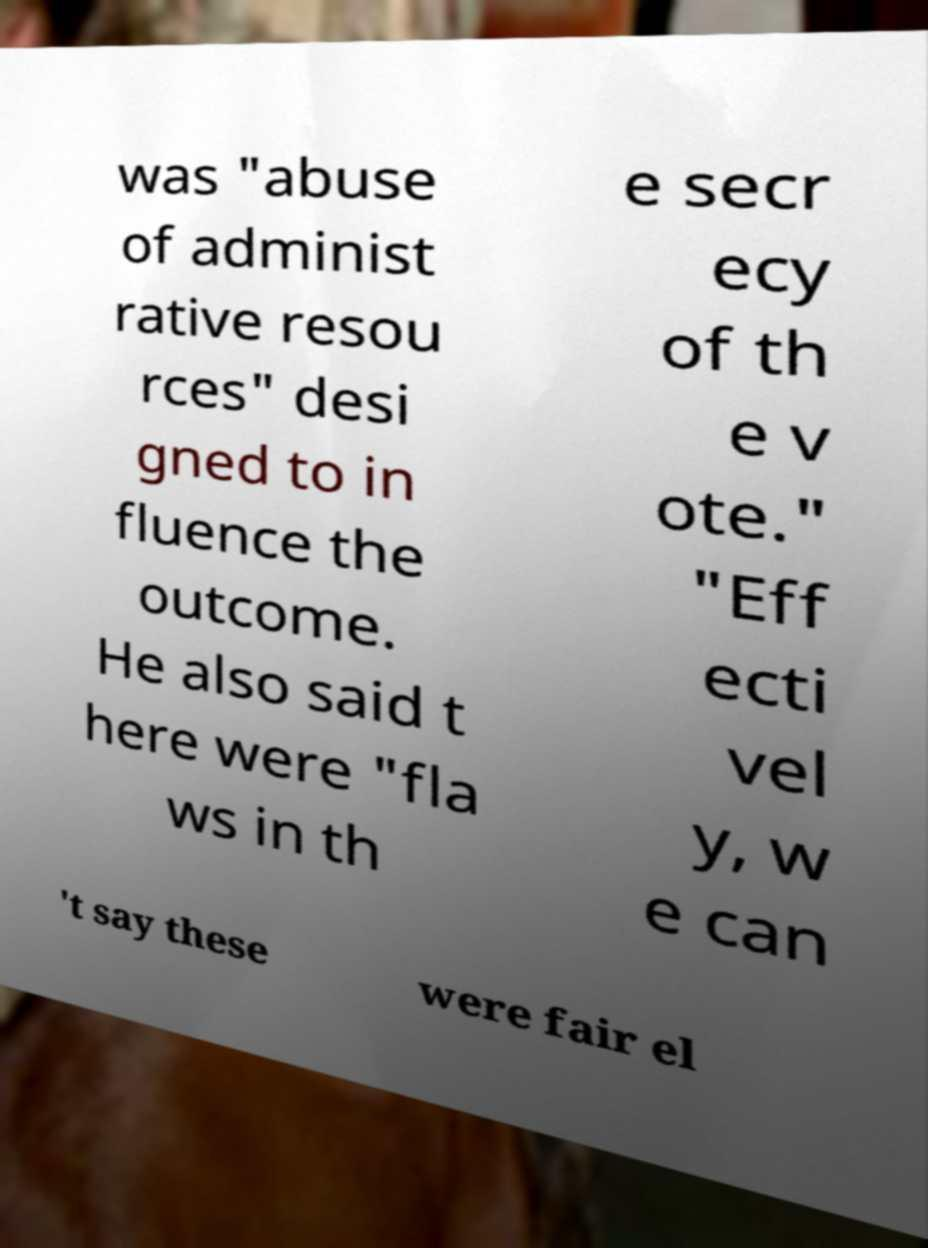What messages or text are displayed in this image? I need them in a readable, typed format. was "abuse of administ rative resou rces" desi gned to in fluence the outcome. He also said t here were "fla ws in th e secr ecy of th e v ote." "Eff ecti vel y, w e can 't say these were fair el 